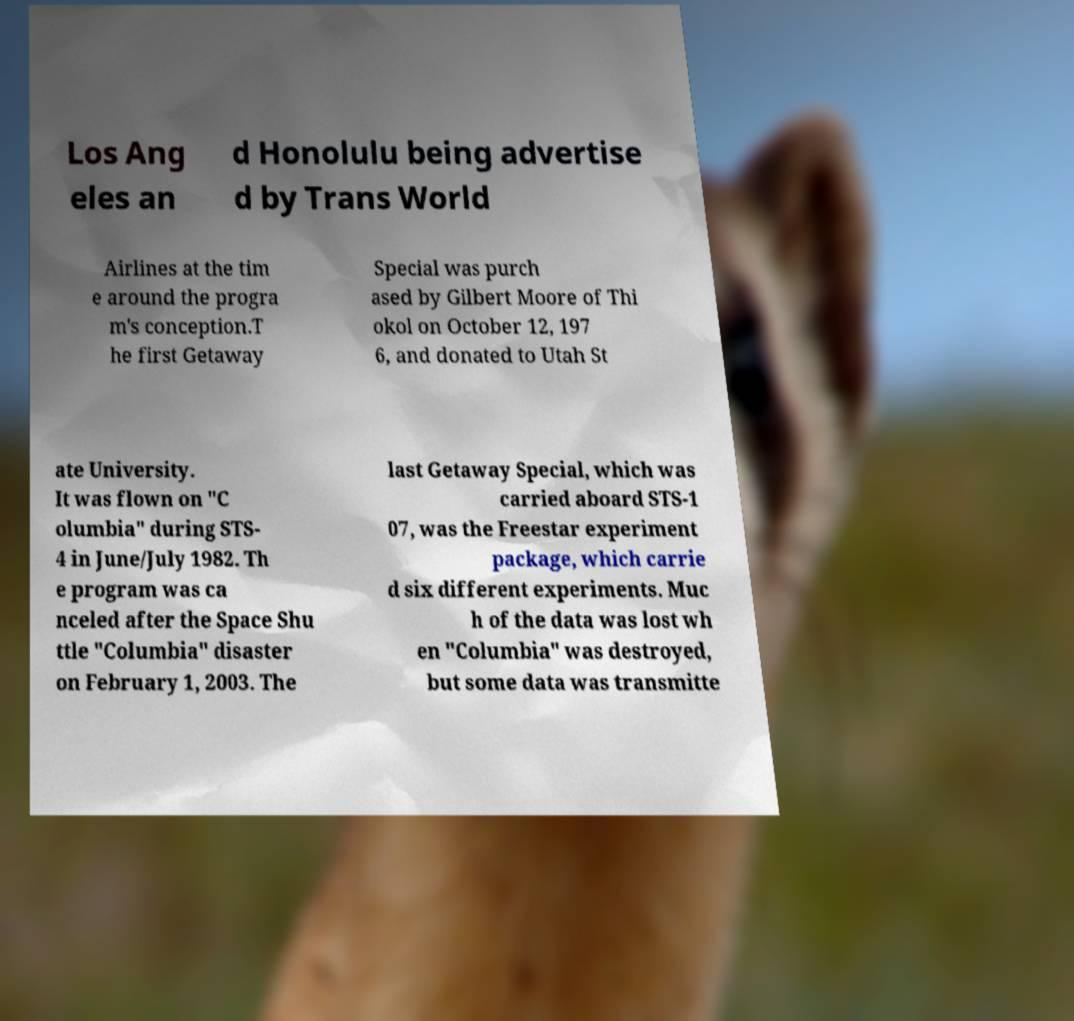Please read and relay the text visible in this image. What does it say? Los Ang eles an d Honolulu being advertise d by Trans World Airlines at the tim e around the progra m's conception.T he first Getaway Special was purch ased by Gilbert Moore of Thi okol on October 12, 197 6, and donated to Utah St ate University. It was flown on "C olumbia" during STS- 4 in June/July 1982. Th e program was ca nceled after the Space Shu ttle "Columbia" disaster on February 1, 2003. The last Getaway Special, which was carried aboard STS-1 07, was the Freestar experiment package, which carrie d six different experiments. Muc h of the data was lost wh en "Columbia" was destroyed, but some data was transmitte 